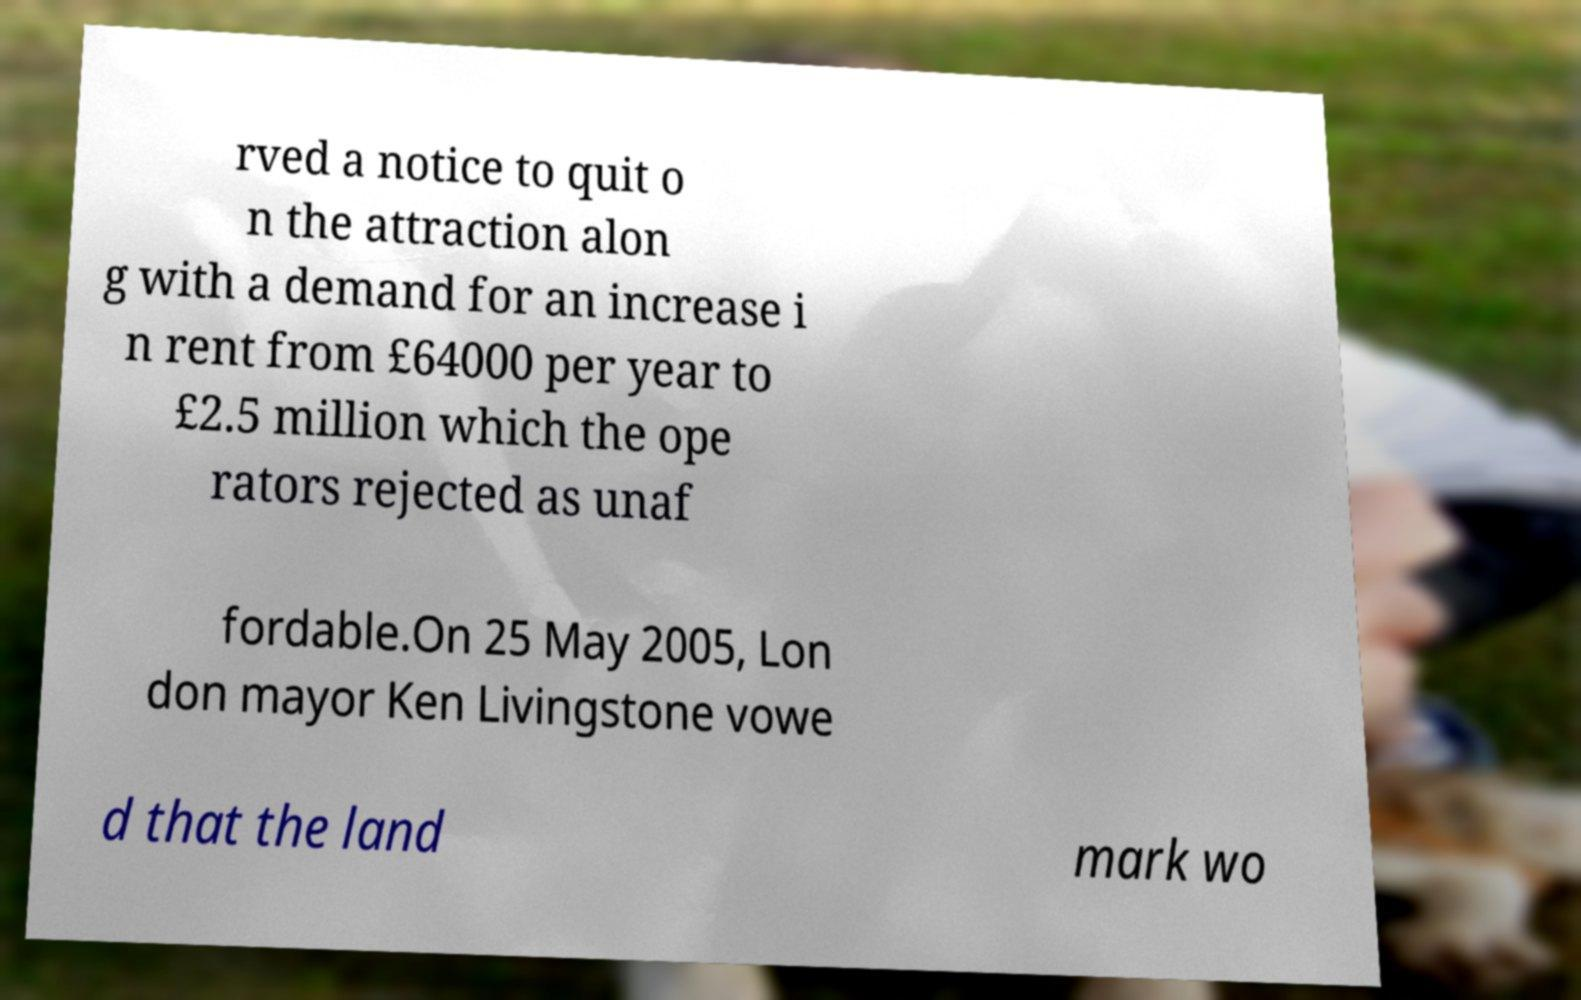I need the written content from this picture converted into text. Can you do that? rved a notice to quit o n the attraction alon g with a demand for an increase i n rent from £64000 per year to £2.5 million which the ope rators rejected as unaf fordable.On 25 May 2005, Lon don mayor Ken Livingstone vowe d that the land mark wo 